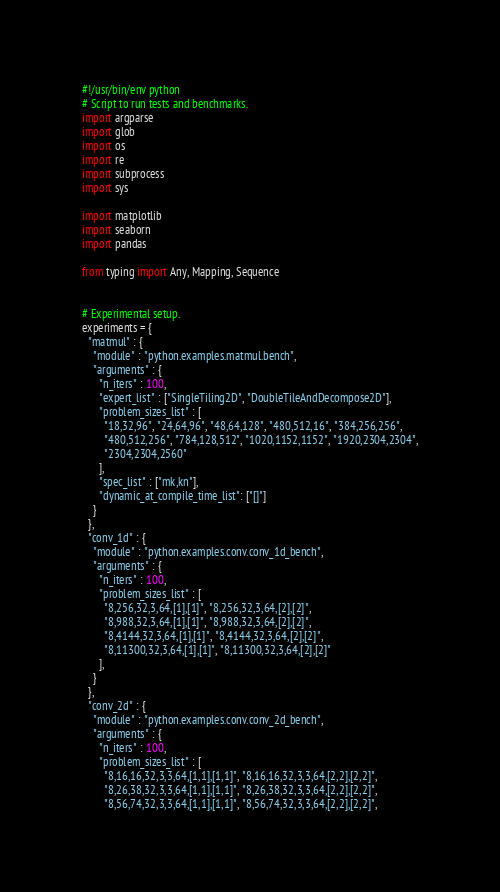<code> <loc_0><loc_0><loc_500><loc_500><_Python_>#!/usr/bin/env python
# Script to run tests and benchmarks.
import argparse
import glob
import os
import re
import subprocess
import sys

import matplotlib
import seaborn
import pandas

from typing import Any, Mapping, Sequence


# Experimental setup.
experiments = {
  "matmul" : {
    "module" : "python.examples.matmul.bench",
    "arguments" : {
      "n_iters" : 100,
      "expert_list" : ["SingleTiling2D", "DoubleTileAndDecompose2D"],
      "problem_sizes_list" : [
        "18,32,96", "24,64,96", "48,64,128", "480,512,16", "384,256,256",
        "480,512,256", "784,128,512", "1020,1152,1152", "1920,2304,2304",
        "2304,2304,2560"
      ],
      "spec_list" : ["mk,kn"],
      "dynamic_at_compile_time_list": ["[]"]
    }
  },
  "conv_1d" : {
    "module" : "python.examples.conv.conv_1d_bench",
    "arguments" : {
      "n_iters" : 100,
      "problem_sizes_list" : [
        "8,256,32,3,64,[1],[1]", "8,256,32,3,64,[2],[2]",
        "8,988,32,3,64,[1],[1]", "8,988,32,3,64,[2],[2]",
        "8,4144,32,3,64,[1],[1]", "8,4144,32,3,64,[2],[2]",
        "8,11300,32,3,64,[1],[1]", "8,11300,32,3,64,[2],[2]"
      ],
    }
  },
  "conv_2d" : {
    "module" : "python.examples.conv.conv_2d_bench",
    "arguments" : {
      "n_iters" : 100,
      "problem_sizes_list" : [
        "8,16,16,32,3,3,64,[1,1],[1,1]", "8,16,16,32,3,3,64,[2,2],[2,2]",
        "8,26,38,32,3,3,64,[1,1],[1,1]", "8,26,38,32,3,3,64,[2,2],[2,2]",
        "8,56,74,32,3,3,64,[1,1],[1,1]", "8,56,74,32,3,3,64,[2,2],[2,2]",</code> 